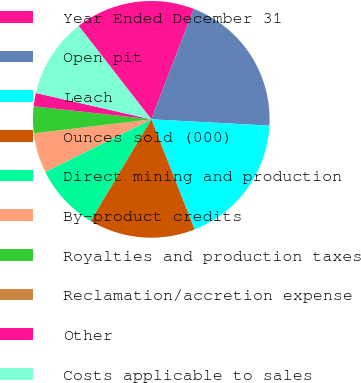<chart> <loc_0><loc_0><loc_500><loc_500><pie_chart><fcel>Year Ended December 31<fcel>Open pit<fcel>Leach<fcel>Ounces sold (000)<fcel>Direct mining and production<fcel>By-product credits<fcel>Royalties and production taxes<fcel>Reclamation/accretion expense<fcel>Other<fcel>Costs applicable to sales<nl><fcel>16.36%<fcel>20.0%<fcel>18.18%<fcel>14.55%<fcel>9.09%<fcel>5.45%<fcel>3.64%<fcel>0.0%<fcel>1.82%<fcel>10.91%<nl></chart> 